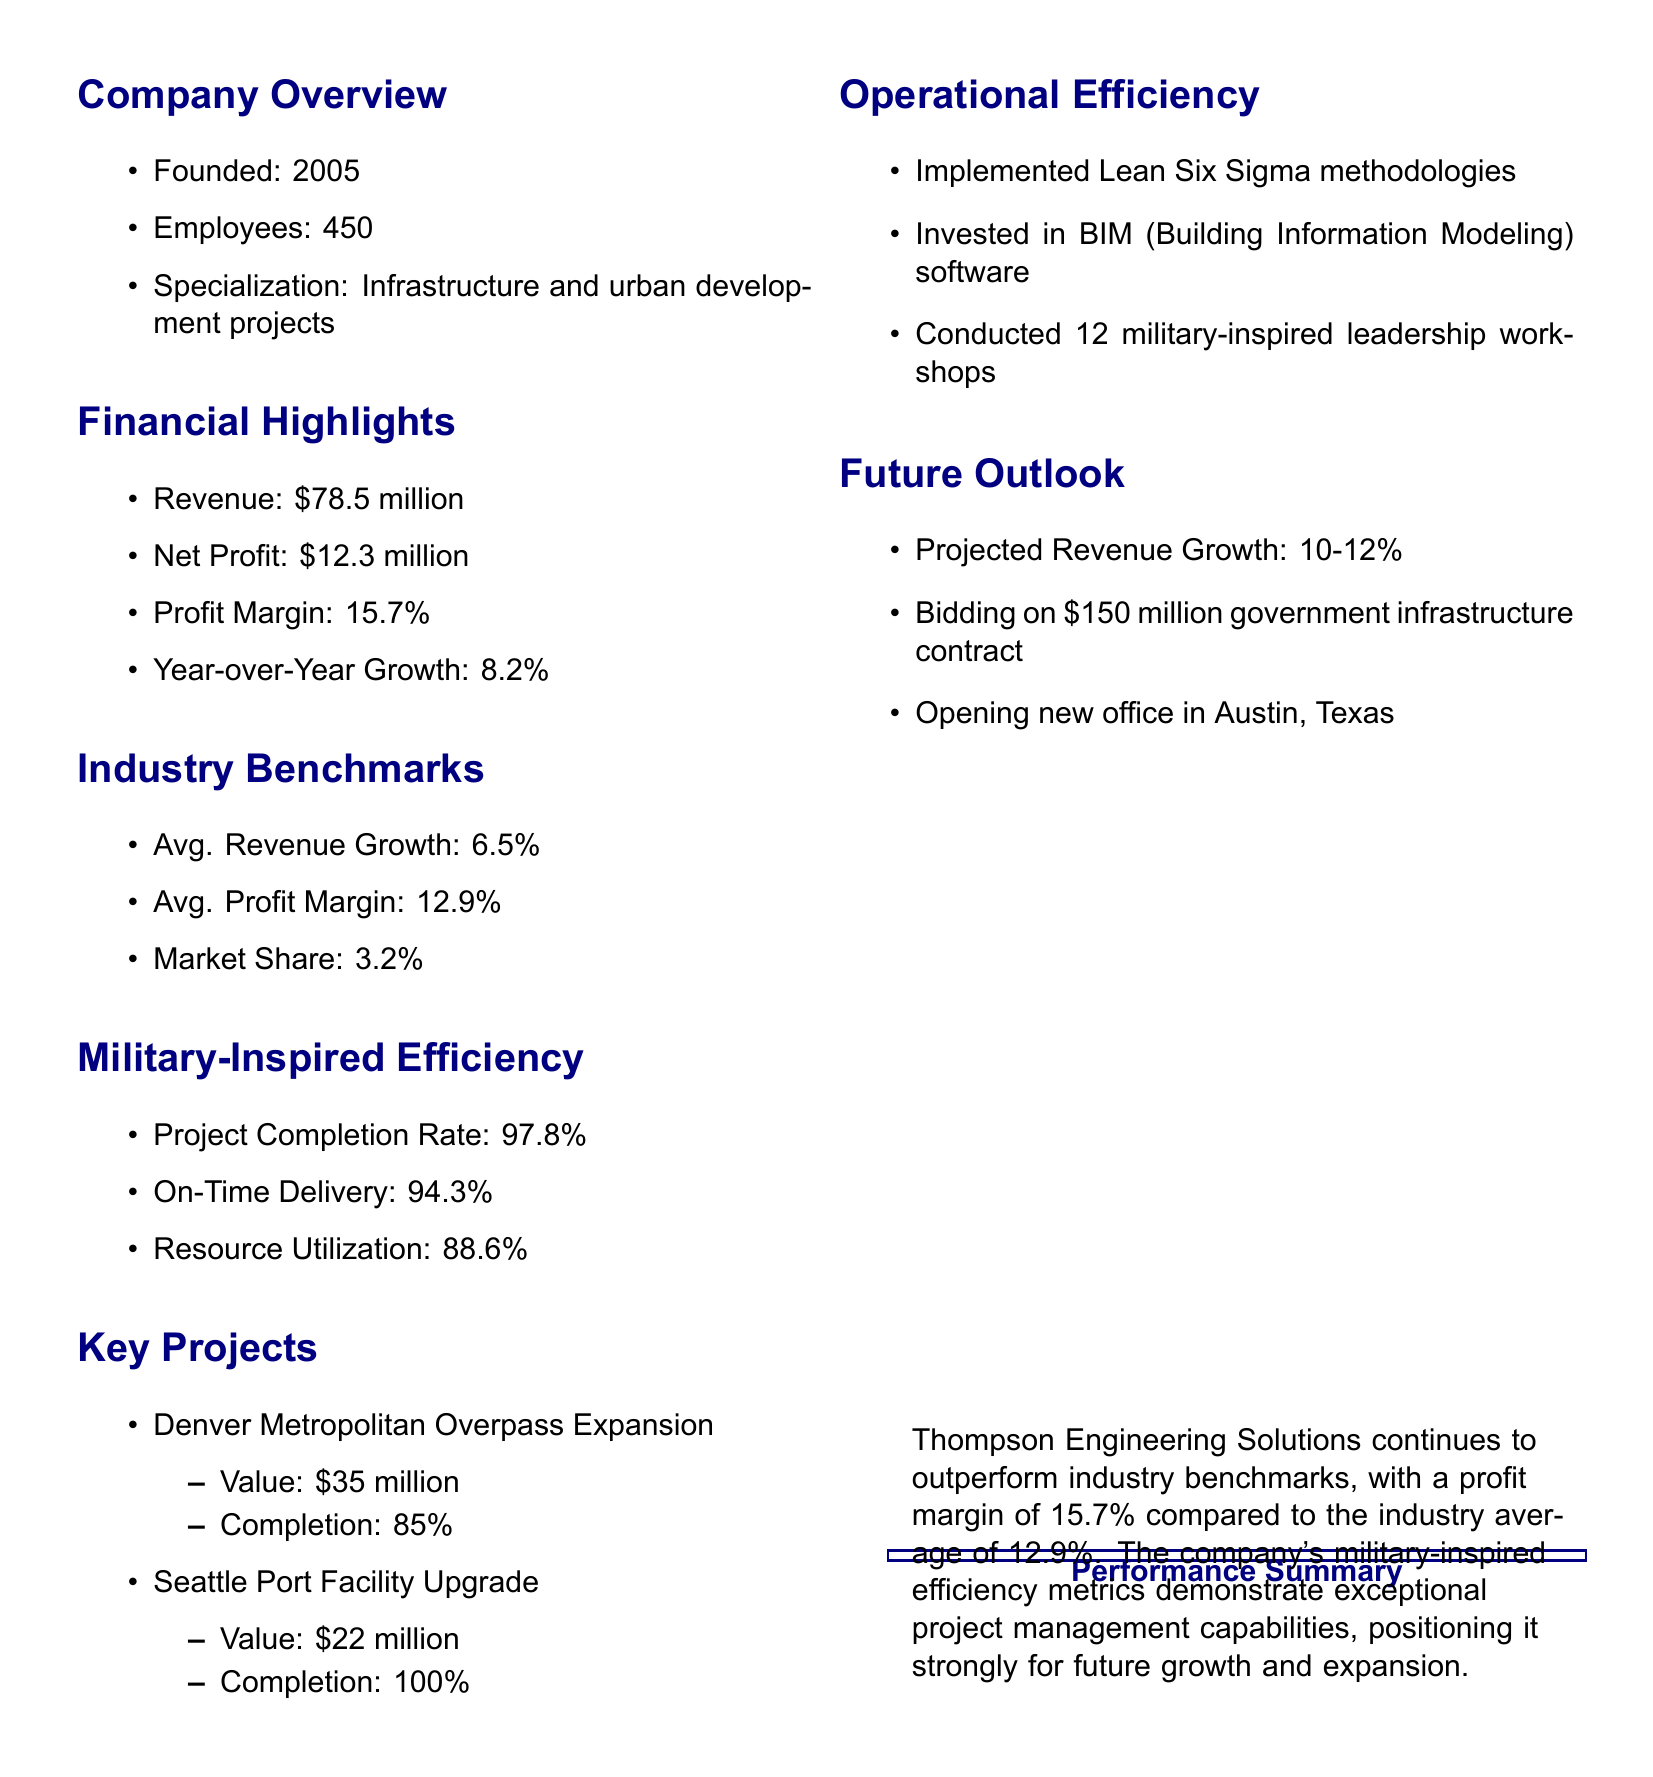What is the company's revenue? The revenue for Thompson Engineering Solutions is listed as $78.5 million in the financial highlights section.
Answer: $78.5 million What is the profit margin compared to the industry benchmark? The company's profit margin is 15.7%, which is compared to the industry average of 12.9%.
Answer: 15.7% What is the projected revenue growth percentage? The document states the projected revenue growth for the future is between 10-12%.
Answer: 10-12% How many employees does Thompson Engineering Solutions have? The company overview section mentions the total number of employees is 450.
Answer: 450 What is the completion status of the Seattle Port Facility Upgrade project? This key project is noted as being fully completed at 100%.
Answer: 100% How much is Thompson Engineering Solutions bidding for a government infrastructure contract? The future outlook mentions the company is bidding on a contract worth $150 million.
Answer: $150 million What methodology has been implemented for operational efficiency? The report indicates that Lean Six Sigma methodologies have been implemented as part of cost reduction initiatives.
Answer: Lean Six Sigma What is the on-time delivery percentage? The military efficiency metric states the on-time delivery rate is 94.3%.
Answer: 94.3% What year was Thompson Engineering Solutions founded? The company overview specifies that it was founded in 2005.
Answer: 2005 